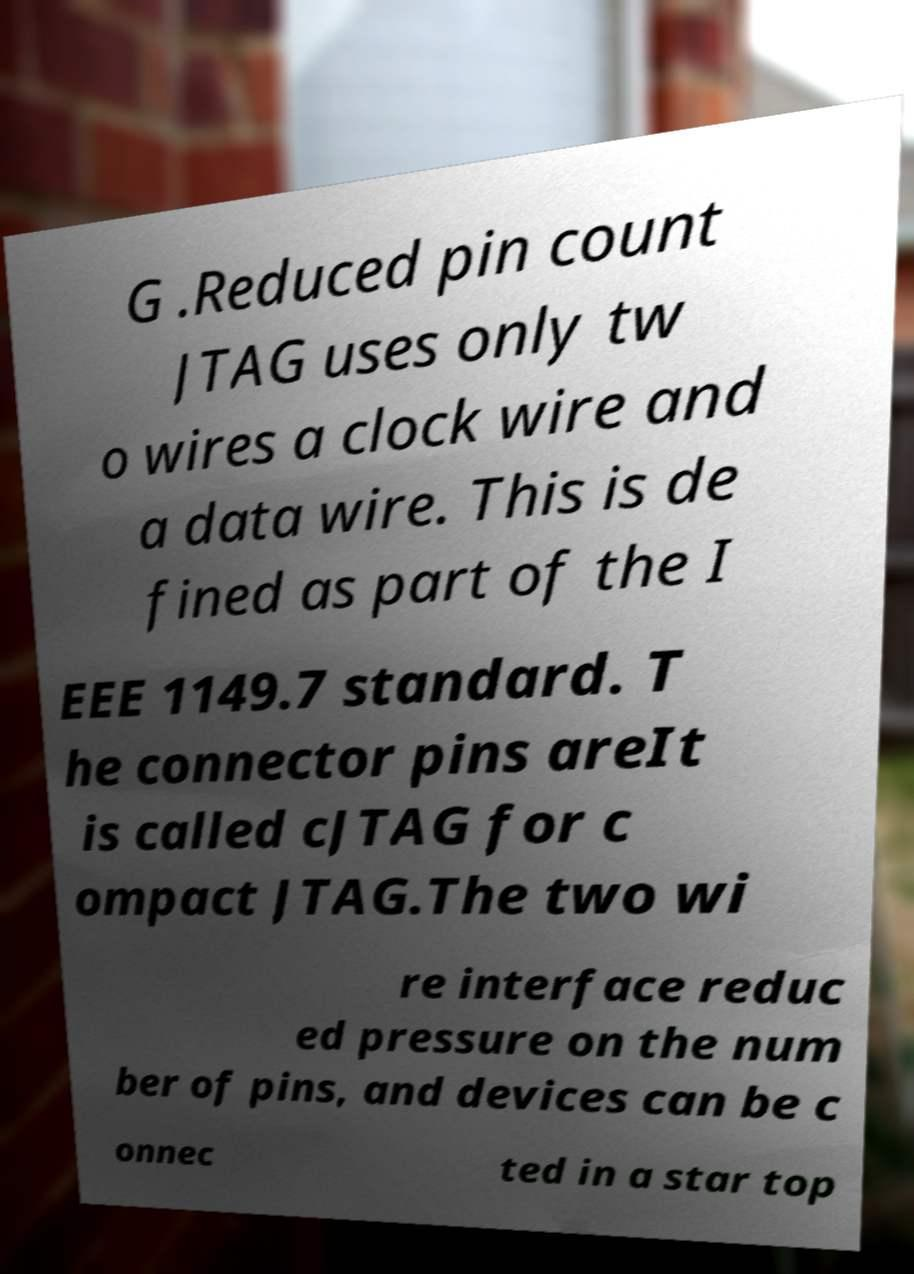I need the written content from this picture converted into text. Can you do that? G .Reduced pin count JTAG uses only tw o wires a clock wire and a data wire. This is de fined as part of the I EEE 1149.7 standard. T he connector pins areIt is called cJTAG for c ompact JTAG.The two wi re interface reduc ed pressure on the num ber of pins, and devices can be c onnec ted in a star top 